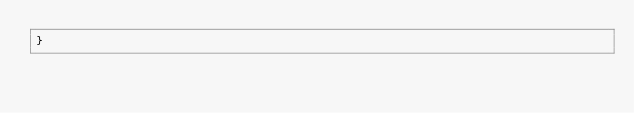Convert code to text. <code><loc_0><loc_0><loc_500><loc_500><_Awk_>}
</code> 